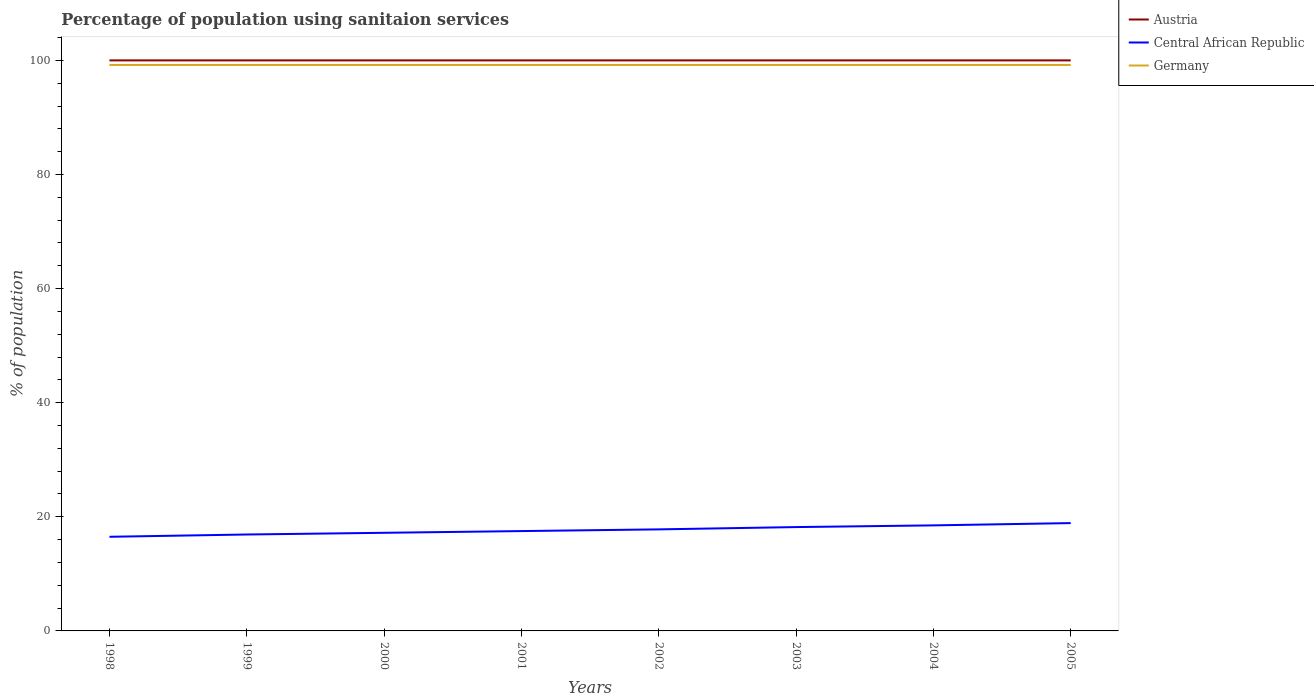How many different coloured lines are there?
Offer a very short reply. 3. Is the number of lines equal to the number of legend labels?
Offer a terse response. Yes. Across all years, what is the maximum percentage of population using sanitaion services in Central African Republic?
Your answer should be compact. 16.5. What is the total percentage of population using sanitaion services in Central African Republic in the graph?
Make the answer very short. -1. What is the difference between the highest and the lowest percentage of population using sanitaion services in Austria?
Give a very brief answer. 0. Is the percentage of population using sanitaion services in Central African Republic strictly greater than the percentage of population using sanitaion services in Germany over the years?
Your answer should be compact. Yes. How many years are there in the graph?
Provide a short and direct response. 8. Does the graph contain any zero values?
Offer a terse response. No. Does the graph contain grids?
Your response must be concise. No. Where does the legend appear in the graph?
Keep it short and to the point. Top right. How are the legend labels stacked?
Provide a short and direct response. Vertical. What is the title of the graph?
Make the answer very short. Percentage of population using sanitaion services. Does "Curacao" appear as one of the legend labels in the graph?
Your answer should be compact. No. What is the label or title of the X-axis?
Your answer should be very brief. Years. What is the label or title of the Y-axis?
Keep it short and to the point. % of population. What is the % of population in Germany in 1998?
Your response must be concise. 99.2. What is the % of population in Central African Republic in 1999?
Your response must be concise. 16.9. What is the % of population of Germany in 1999?
Your answer should be very brief. 99.2. What is the % of population of Central African Republic in 2000?
Offer a very short reply. 17.2. What is the % of population in Germany in 2000?
Keep it short and to the point. 99.2. What is the % of population of Germany in 2001?
Your answer should be very brief. 99.2. What is the % of population in Austria in 2002?
Provide a short and direct response. 100. What is the % of population of Germany in 2002?
Give a very brief answer. 99.2. What is the % of population in Austria in 2003?
Provide a short and direct response. 100. What is the % of population in Central African Republic in 2003?
Keep it short and to the point. 18.2. What is the % of population in Germany in 2003?
Offer a terse response. 99.2. What is the % of population of Austria in 2004?
Keep it short and to the point. 100. What is the % of population in Germany in 2004?
Your response must be concise. 99.2. What is the % of population of Austria in 2005?
Give a very brief answer. 100. What is the % of population of Germany in 2005?
Provide a short and direct response. 99.2. Across all years, what is the maximum % of population in Germany?
Offer a very short reply. 99.2. Across all years, what is the minimum % of population in Germany?
Provide a succinct answer. 99.2. What is the total % of population in Austria in the graph?
Provide a short and direct response. 800. What is the total % of population of Central African Republic in the graph?
Your answer should be very brief. 141.5. What is the total % of population of Germany in the graph?
Your answer should be very brief. 793.6. What is the difference between the % of population in Austria in 1998 and that in 1999?
Offer a terse response. 0. What is the difference between the % of population of Central African Republic in 1998 and that in 1999?
Your answer should be compact. -0.4. What is the difference between the % of population in Germany in 1998 and that in 1999?
Ensure brevity in your answer.  0. What is the difference between the % of population of Austria in 1998 and that in 2000?
Provide a succinct answer. 0. What is the difference between the % of population of Austria in 1998 and that in 2001?
Offer a terse response. 0. What is the difference between the % of population of Central African Republic in 1998 and that in 2001?
Give a very brief answer. -1. What is the difference between the % of population in Germany in 1998 and that in 2001?
Give a very brief answer. 0. What is the difference between the % of population of Austria in 1998 and that in 2002?
Keep it short and to the point. 0. What is the difference between the % of population of Central African Republic in 1998 and that in 2002?
Give a very brief answer. -1.3. What is the difference between the % of population of Germany in 1998 and that in 2002?
Give a very brief answer. 0. What is the difference between the % of population of Austria in 1998 and that in 2003?
Offer a very short reply. 0. What is the difference between the % of population in Germany in 1998 and that in 2003?
Give a very brief answer. 0. What is the difference between the % of population in Central African Republic in 1998 and that in 2004?
Keep it short and to the point. -2. What is the difference between the % of population in Germany in 1998 and that in 2005?
Your response must be concise. 0. What is the difference between the % of population in Germany in 1999 and that in 2000?
Ensure brevity in your answer.  0. What is the difference between the % of population in Central African Republic in 1999 and that in 2001?
Your answer should be very brief. -0.6. What is the difference between the % of population of Germany in 1999 and that in 2001?
Give a very brief answer. 0. What is the difference between the % of population in Austria in 1999 and that in 2002?
Keep it short and to the point. 0. What is the difference between the % of population of Central African Republic in 1999 and that in 2002?
Offer a terse response. -0.9. What is the difference between the % of population of Germany in 1999 and that in 2002?
Your answer should be compact. 0. What is the difference between the % of population in Austria in 1999 and that in 2003?
Provide a succinct answer. 0. What is the difference between the % of population of Central African Republic in 1999 and that in 2003?
Make the answer very short. -1.3. What is the difference between the % of population of Germany in 1999 and that in 2003?
Your answer should be compact. 0. What is the difference between the % of population in Central African Republic in 1999 and that in 2004?
Your answer should be very brief. -1.6. What is the difference between the % of population of Austria in 1999 and that in 2005?
Your answer should be very brief. 0. What is the difference between the % of population of Germany in 1999 and that in 2005?
Your answer should be very brief. 0. What is the difference between the % of population of Central African Republic in 2000 and that in 2001?
Your response must be concise. -0.3. What is the difference between the % of population in Germany in 2000 and that in 2001?
Make the answer very short. 0. What is the difference between the % of population in Austria in 2000 and that in 2002?
Your answer should be very brief. 0. What is the difference between the % of population of Germany in 2000 and that in 2002?
Provide a succinct answer. 0. What is the difference between the % of population in Germany in 2000 and that in 2003?
Offer a terse response. 0. What is the difference between the % of population of Austria in 2000 and that in 2004?
Your answer should be compact. 0. What is the difference between the % of population of Austria in 2000 and that in 2005?
Keep it short and to the point. 0. What is the difference between the % of population of Central African Republic in 2001 and that in 2002?
Make the answer very short. -0.3. What is the difference between the % of population of Austria in 2001 and that in 2003?
Ensure brevity in your answer.  0. What is the difference between the % of population of Austria in 2001 and that in 2004?
Make the answer very short. 0. What is the difference between the % of population in Germany in 2001 and that in 2005?
Provide a succinct answer. 0. What is the difference between the % of population of Central African Republic in 2002 and that in 2003?
Provide a succinct answer. -0.4. What is the difference between the % of population in Austria in 2002 and that in 2004?
Your answer should be compact. 0. What is the difference between the % of population in Central African Republic in 2002 and that in 2004?
Your response must be concise. -0.7. What is the difference between the % of population of Central African Republic in 2002 and that in 2005?
Your answer should be compact. -1.1. What is the difference between the % of population of Germany in 2002 and that in 2005?
Provide a succinct answer. 0. What is the difference between the % of population in Austria in 2003 and that in 2004?
Offer a very short reply. 0. What is the difference between the % of population of Central African Republic in 2003 and that in 2004?
Your answer should be very brief. -0.3. What is the difference between the % of population of Germany in 2003 and that in 2004?
Your answer should be compact. 0. What is the difference between the % of population in Austria in 2003 and that in 2005?
Provide a succinct answer. 0. What is the difference between the % of population in Central African Republic in 2003 and that in 2005?
Make the answer very short. -0.7. What is the difference between the % of population of Central African Republic in 2004 and that in 2005?
Offer a terse response. -0.4. What is the difference between the % of population of Germany in 2004 and that in 2005?
Give a very brief answer. 0. What is the difference between the % of population in Austria in 1998 and the % of population in Central African Republic in 1999?
Make the answer very short. 83.1. What is the difference between the % of population in Austria in 1998 and the % of population in Germany in 1999?
Make the answer very short. 0.8. What is the difference between the % of population of Central African Republic in 1998 and the % of population of Germany in 1999?
Give a very brief answer. -82.7. What is the difference between the % of population of Austria in 1998 and the % of population of Central African Republic in 2000?
Your answer should be compact. 82.8. What is the difference between the % of population of Austria in 1998 and the % of population of Germany in 2000?
Offer a very short reply. 0.8. What is the difference between the % of population of Central African Republic in 1998 and the % of population of Germany in 2000?
Your response must be concise. -82.7. What is the difference between the % of population in Austria in 1998 and the % of population in Central African Republic in 2001?
Provide a succinct answer. 82.5. What is the difference between the % of population in Austria in 1998 and the % of population in Germany in 2001?
Make the answer very short. 0.8. What is the difference between the % of population in Central African Republic in 1998 and the % of population in Germany in 2001?
Give a very brief answer. -82.7. What is the difference between the % of population in Austria in 1998 and the % of population in Central African Republic in 2002?
Offer a terse response. 82.2. What is the difference between the % of population in Austria in 1998 and the % of population in Germany in 2002?
Offer a terse response. 0.8. What is the difference between the % of population of Central African Republic in 1998 and the % of population of Germany in 2002?
Provide a short and direct response. -82.7. What is the difference between the % of population in Austria in 1998 and the % of population in Central African Republic in 2003?
Your response must be concise. 81.8. What is the difference between the % of population in Central African Republic in 1998 and the % of population in Germany in 2003?
Your answer should be compact. -82.7. What is the difference between the % of population in Austria in 1998 and the % of population in Central African Republic in 2004?
Offer a terse response. 81.5. What is the difference between the % of population of Central African Republic in 1998 and the % of population of Germany in 2004?
Keep it short and to the point. -82.7. What is the difference between the % of population of Austria in 1998 and the % of population of Central African Republic in 2005?
Give a very brief answer. 81.1. What is the difference between the % of population in Central African Republic in 1998 and the % of population in Germany in 2005?
Keep it short and to the point. -82.7. What is the difference between the % of population of Austria in 1999 and the % of population of Central African Republic in 2000?
Provide a short and direct response. 82.8. What is the difference between the % of population of Central African Republic in 1999 and the % of population of Germany in 2000?
Offer a terse response. -82.3. What is the difference between the % of population of Austria in 1999 and the % of population of Central African Republic in 2001?
Offer a very short reply. 82.5. What is the difference between the % of population of Central African Republic in 1999 and the % of population of Germany in 2001?
Offer a very short reply. -82.3. What is the difference between the % of population in Austria in 1999 and the % of population in Central African Republic in 2002?
Provide a succinct answer. 82.2. What is the difference between the % of population in Austria in 1999 and the % of population in Germany in 2002?
Keep it short and to the point. 0.8. What is the difference between the % of population in Central African Republic in 1999 and the % of population in Germany in 2002?
Provide a short and direct response. -82.3. What is the difference between the % of population of Austria in 1999 and the % of population of Central African Republic in 2003?
Make the answer very short. 81.8. What is the difference between the % of population of Central African Republic in 1999 and the % of population of Germany in 2003?
Your answer should be compact. -82.3. What is the difference between the % of population in Austria in 1999 and the % of population in Central African Republic in 2004?
Provide a short and direct response. 81.5. What is the difference between the % of population of Austria in 1999 and the % of population of Germany in 2004?
Your response must be concise. 0.8. What is the difference between the % of population in Central African Republic in 1999 and the % of population in Germany in 2004?
Give a very brief answer. -82.3. What is the difference between the % of population of Austria in 1999 and the % of population of Central African Republic in 2005?
Provide a succinct answer. 81.1. What is the difference between the % of population of Central African Republic in 1999 and the % of population of Germany in 2005?
Provide a succinct answer. -82.3. What is the difference between the % of population of Austria in 2000 and the % of population of Central African Republic in 2001?
Your answer should be compact. 82.5. What is the difference between the % of population of Austria in 2000 and the % of population of Germany in 2001?
Your answer should be compact. 0.8. What is the difference between the % of population of Central African Republic in 2000 and the % of population of Germany in 2001?
Your response must be concise. -82. What is the difference between the % of population in Austria in 2000 and the % of population in Central African Republic in 2002?
Make the answer very short. 82.2. What is the difference between the % of population of Austria in 2000 and the % of population of Germany in 2002?
Provide a succinct answer. 0.8. What is the difference between the % of population in Central African Republic in 2000 and the % of population in Germany in 2002?
Provide a succinct answer. -82. What is the difference between the % of population in Austria in 2000 and the % of population in Central African Republic in 2003?
Your answer should be very brief. 81.8. What is the difference between the % of population of Austria in 2000 and the % of population of Germany in 2003?
Keep it short and to the point. 0.8. What is the difference between the % of population in Central African Republic in 2000 and the % of population in Germany in 2003?
Your answer should be very brief. -82. What is the difference between the % of population in Austria in 2000 and the % of population in Central African Republic in 2004?
Provide a short and direct response. 81.5. What is the difference between the % of population in Central African Republic in 2000 and the % of population in Germany in 2004?
Ensure brevity in your answer.  -82. What is the difference between the % of population in Austria in 2000 and the % of population in Central African Republic in 2005?
Make the answer very short. 81.1. What is the difference between the % of population in Central African Republic in 2000 and the % of population in Germany in 2005?
Offer a very short reply. -82. What is the difference between the % of population in Austria in 2001 and the % of population in Central African Republic in 2002?
Ensure brevity in your answer.  82.2. What is the difference between the % of population of Central African Republic in 2001 and the % of population of Germany in 2002?
Keep it short and to the point. -81.7. What is the difference between the % of population of Austria in 2001 and the % of population of Central African Republic in 2003?
Ensure brevity in your answer.  81.8. What is the difference between the % of population of Central African Republic in 2001 and the % of population of Germany in 2003?
Give a very brief answer. -81.7. What is the difference between the % of population in Austria in 2001 and the % of population in Central African Republic in 2004?
Offer a terse response. 81.5. What is the difference between the % of population of Austria in 2001 and the % of population of Germany in 2004?
Provide a succinct answer. 0.8. What is the difference between the % of population in Central African Republic in 2001 and the % of population in Germany in 2004?
Give a very brief answer. -81.7. What is the difference between the % of population of Austria in 2001 and the % of population of Central African Republic in 2005?
Your answer should be compact. 81.1. What is the difference between the % of population in Central African Republic in 2001 and the % of population in Germany in 2005?
Your answer should be very brief. -81.7. What is the difference between the % of population of Austria in 2002 and the % of population of Central African Republic in 2003?
Offer a terse response. 81.8. What is the difference between the % of population in Austria in 2002 and the % of population in Germany in 2003?
Ensure brevity in your answer.  0.8. What is the difference between the % of population of Central African Republic in 2002 and the % of population of Germany in 2003?
Ensure brevity in your answer.  -81.4. What is the difference between the % of population of Austria in 2002 and the % of population of Central African Republic in 2004?
Make the answer very short. 81.5. What is the difference between the % of population in Austria in 2002 and the % of population in Germany in 2004?
Keep it short and to the point. 0.8. What is the difference between the % of population in Central African Republic in 2002 and the % of population in Germany in 2004?
Give a very brief answer. -81.4. What is the difference between the % of population of Austria in 2002 and the % of population of Central African Republic in 2005?
Your answer should be very brief. 81.1. What is the difference between the % of population in Austria in 2002 and the % of population in Germany in 2005?
Keep it short and to the point. 0.8. What is the difference between the % of population of Central African Republic in 2002 and the % of population of Germany in 2005?
Offer a terse response. -81.4. What is the difference between the % of population in Austria in 2003 and the % of population in Central African Republic in 2004?
Give a very brief answer. 81.5. What is the difference between the % of population in Austria in 2003 and the % of population in Germany in 2004?
Your response must be concise. 0.8. What is the difference between the % of population in Central African Republic in 2003 and the % of population in Germany in 2004?
Make the answer very short. -81. What is the difference between the % of population in Austria in 2003 and the % of population in Central African Republic in 2005?
Your answer should be compact. 81.1. What is the difference between the % of population in Austria in 2003 and the % of population in Germany in 2005?
Your response must be concise. 0.8. What is the difference between the % of population in Central African Republic in 2003 and the % of population in Germany in 2005?
Make the answer very short. -81. What is the difference between the % of population of Austria in 2004 and the % of population of Central African Republic in 2005?
Ensure brevity in your answer.  81.1. What is the difference between the % of population of Central African Republic in 2004 and the % of population of Germany in 2005?
Provide a succinct answer. -80.7. What is the average % of population in Central African Republic per year?
Provide a short and direct response. 17.69. What is the average % of population of Germany per year?
Give a very brief answer. 99.2. In the year 1998, what is the difference between the % of population of Austria and % of population of Central African Republic?
Offer a very short reply. 83.5. In the year 1998, what is the difference between the % of population of Austria and % of population of Germany?
Offer a very short reply. 0.8. In the year 1998, what is the difference between the % of population of Central African Republic and % of population of Germany?
Ensure brevity in your answer.  -82.7. In the year 1999, what is the difference between the % of population of Austria and % of population of Central African Republic?
Ensure brevity in your answer.  83.1. In the year 1999, what is the difference between the % of population of Central African Republic and % of population of Germany?
Offer a very short reply. -82.3. In the year 2000, what is the difference between the % of population in Austria and % of population in Central African Republic?
Your answer should be very brief. 82.8. In the year 2000, what is the difference between the % of population of Austria and % of population of Germany?
Your answer should be compact. 0.8. In the year 2000, what is the difference between the % of population of Central African Republic and % of population of Germany?
Keep it short and to the point. -82. In the year 2001, what is the difference between the % of population in Austria and % of population in Central African Republic?
Provide a succinct answer. 82.5. In the year 2001, what is the difference between the % of population in Austria and % of population in Germany?
Your answer should be compact. 0.8. In the year 2001, what is the difference between the % of population of Central African Republic and % of population of Germany?
Give a very brief answer. -81.7. In the year 2002, what is the difference between the % of population of Austria and % of population of Central African Republic?
Make the answer very short. 82.2. In the year 2002, what is the difference between the % of population in Central African Republic and % of population in Germany?
Provide a succinct answer. -81.4. In the year 2003, what is the difference between the % of population of Austria and % of population of Central African Republic?
Provide a succinct answer. 81.8. In the year 2003, what is the difference between the % of population of Austria and % of population of Germany?
Offer a very short reply. 0.8. In the year 2003, what is the difference between the % of population of Central African Republic and % of population of Germany?
Offer a very short reply. -81. In the year 2004, what is the difference between the % of population of Austria and % of population of Central African Republic?
Your answer should be compact. 81.5. In the year 2004, what is the difference between the % of population in Austria and % of population in Germany?
Provide a succinct answer. 0.8. In the year 2004, what is the difference between the % of population in Central African Republic and % of population in Germany?
Provide a short and direct response. -80.7. In the year 2005, what is the difference between the % of population in Austria and % of population in Central African Republic?
Your response must be concise. 81.1. In the year 2005, what is the difference between the % of population in Austria and % of population in Germany?
Provide a succinct answer. 0.8. In the year 2005, what is the difference between the % of population in Central African Republic and % of population in Germany?
Give a very brief answer. -80.3. What is the ratio of the % of population of Austria in 1998 to that in 1999?
Offer a terse response. 1. What is the ratio of the % of population in Central African Republic in 1998 to that in 1999?
Your response must be concise. 0.98. What is the ratio of the % of population in Germany in 1998 to that in 1999?
Provide a succinct answer. 1. What is the ratio of the % of population in Austria in 1998 to that in 2000?
Give a very brief answer. 1. What is the ratio of the % of population in Central African Republic in 1998 to that in 2000?
Offer a very short reply. 0.96. What is the ratio of the % of population in Austria in 1998 to that in 2001?
Ensure brevity in your answer.  1. What is the ratio of the % of population in Central African Republic in 1998 to that in 2001?
Keep it short and to the point. 0.94. What is the ratio of the % of population in Germany in 1998 to that in 2001?
Provide a succinct answer. 1. What is the ratio of the % of population in Central African Republic in 1998 to that in 2002?
Offer a terse response. 0.93. What is the ratio of the % of population of Germany in 1998 to that in 2002?
Ensure brevity in your answer.  1. What is the ratio of the % of population of Central African Republic in 1998 to that in 2003?
Ensure brevity in your answer.  0.91. What is the ratio of the % of population in Austria in 1998 to that in 2004?
Your answer should be very brief. 1. What is the ratio of the % of population of Central African Republic in 1998 to that in 2004?
Offer a very short reply. 0.89. What is the ratio of the % of population in Austria in 1998 to that in 2005?
Ensure brevity in your answer.  1. What is the ratio of the % of population in Central African Republic in 1998 to that in 2005?
Make the answer very short. 0.87. What is the ratio of the % of population in Germany in 1998 to that in 2005?
Offer a terse response. 1. What is the ratio of the % of population of Austria in 1999 to that in 2000?
Provide a short and direct response. 1. What is the ratio of the % of population in Central African Republic in 1999 to that in 2000?
Your answer should be very brief. 0.98. What is the ratio of the % of population in Central African Republic in 1999 to that in 2001?
Ensure brevity in your answer.  0.97. What is the ratio of the % of population of Austria in 1999 to that in 2002?
Your answer should be compact. 1. What is the ratio of the % of population in Central African Republic in 1999 to that in 2002?
Your answer should be compact. 0.95. What is the ratio of the % of population in Austria in 1999 to that in 2003?
Your answer should be very brief. 1. What is the ratio of the % of population in Germany in 1999 to that in 2003?
Your answer should be very brief. 1. What is the ratio of the % of population of Austria in 1999 to that in 2004?
Provide a short and direct response. 1. What is the ratio of the % of population of Central African Republic in 1999 to that in 2004?
Your answer should be compact. 0.91. What is the ratio of the % of population in Central African Republic in 1999 to that in 2005?
Offer a very short reply. 0.89. What is the ratio of the % of population in Central African Republic in 2000 to that in 2001?
Your answer should be compact. 0.98. What is the ratio of the % of population in Germany in 2000 to that in 2001?
Give a very brief answer. 1. What is the ratio of the % of population of Central African Republic in 2000 to that in 2002?
Your response must be concise. 0.97. What is the ratio of the % of population in Central African Republic in 2000 to that in 2003?
Your answer should be very brief. 0.95. What is the ratio of the % of population of Central African Republic in 2000 to that in 2004?
Give a very brief answer. 0.93. What is the ratio of the % of population of Central African Republic in 2000 to that in 2005?
Provide a short and direct response. 0.91. What is the ratio of the % of population of Germany in 2000 to that in 2005?
Ensure brevity in your answer.  1. What is the ratio of the % of population in Austria in 2001 to that in 2002?
Make the answer very short. 1. What is the ratio of the % of population in Central African Republic in 2001 to that in 2002?
Make the answer very short. 0.98. What is the ratio of the % of population in Central African Republic in 2001 to that in 2003?
Your answer should be compact. 0.96. What is the ratio of the % of population in Germany in 2001 to that in 2003?
Your answer should be compact. 1. What is the ratio of the % of population of Central African Republic in 2001 to that in 2004?
Your answer should be compact. 0.95. What is the ratio of the % of population of Germany in 2001 to that in 2004?
Offer a very short reply. 1. What is the ratio of the % of population in Austria in 2001 to that in 2005?
Give a very brief answer. 1. What is the ratio of the % of population of Central African Republic in 2001 to that in 2005?
Keep it short and to the point. 0.93. What is the ratio of the % of population of Germany in 2001 to that in 2005?
Keep it short and to the point. 1. What is the ratio of the % of population in Austria in 2002 to that in 2003?
Offer a terse response. 1. What is the ratio of the % of population of Austria in 2002 to that in 2004?
Provide a short and direct response. 1. What is the ratio of the % of population of Central African Republic in 2002 to that in 2004?
Your answer should be compact. 0.96. What is the ratio of the % of population in Central African Republic in 2002 to that in 2005?
Your answer should be very brief. 0.94. What is the ratio of the % of population of Germany in 2002 to that in 2005?
Provide a short and direct response. 1. What is the ratio of the % of population of Central African Republic in 2003 to that in 2004?
Your answer should be compact. 0.98. What is the ratio of the % of population of Austria in 2003 to that in 2005?
Your answer should be compact. 1. What is the ratio of the % of population of Central African Republic in 2003 to that in 2005?
Give a very brief answer. 0.96. What is the ratio of the % of population of Central African Republic in 2004 to that in 2005?
Ensure brevity in your answer.  0.98. What is the difference between the highest and the second highest % of population of Central African Republic?
Your answer should be compact. 0.4. What is the difference between the highest and the lowest % of population of Austria?
Offer a terse response. 0. What is the difference between the highest and the lowest % of population of Germany?
Your answer should be compact. 0. 